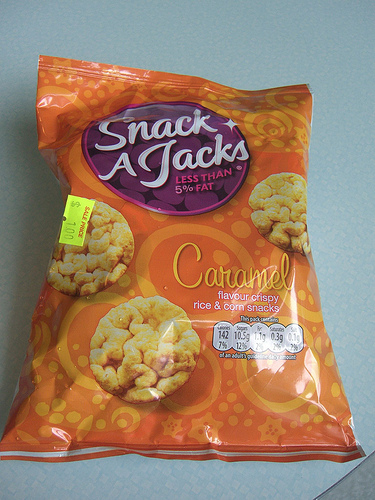<image>
Is the rice cake in the bag? Yes. The rice cake is contained within or inside the bag, showing a containment relationship. 